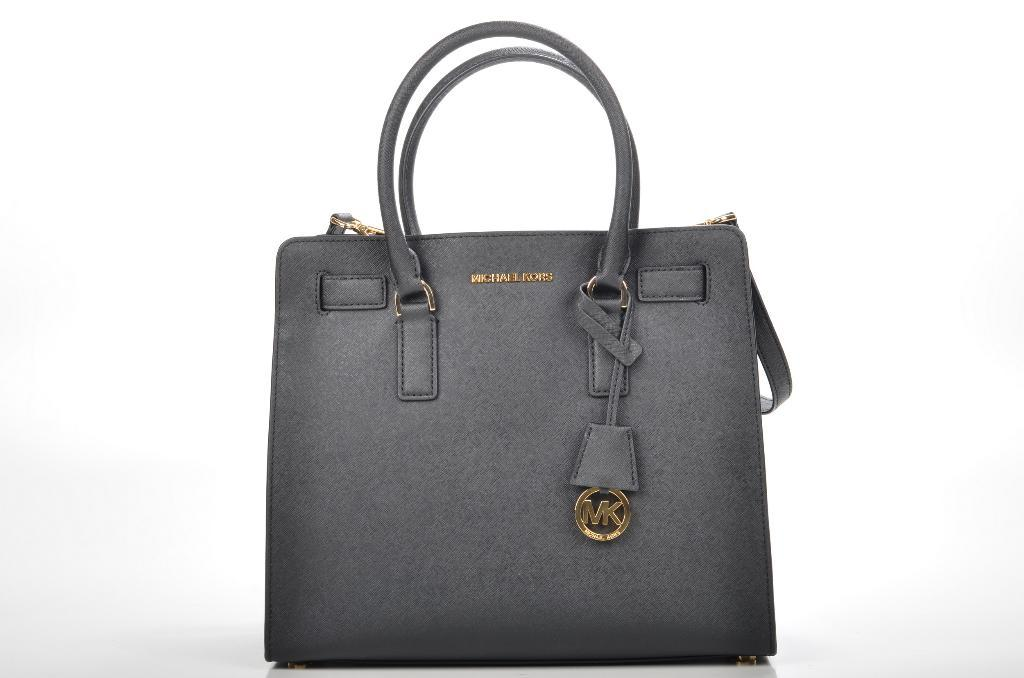What object is present in the image? There is a handbag in the image. Can you describe the color of the handbag? The handbag is grey in color. What type of winter clothing is visible in the image? There is no winter clothing present in the image; it only features a grey handbag. What kind of doll is sitting inside the handbag in the image? There is no doll present in the image; it only features a grey handbag. 